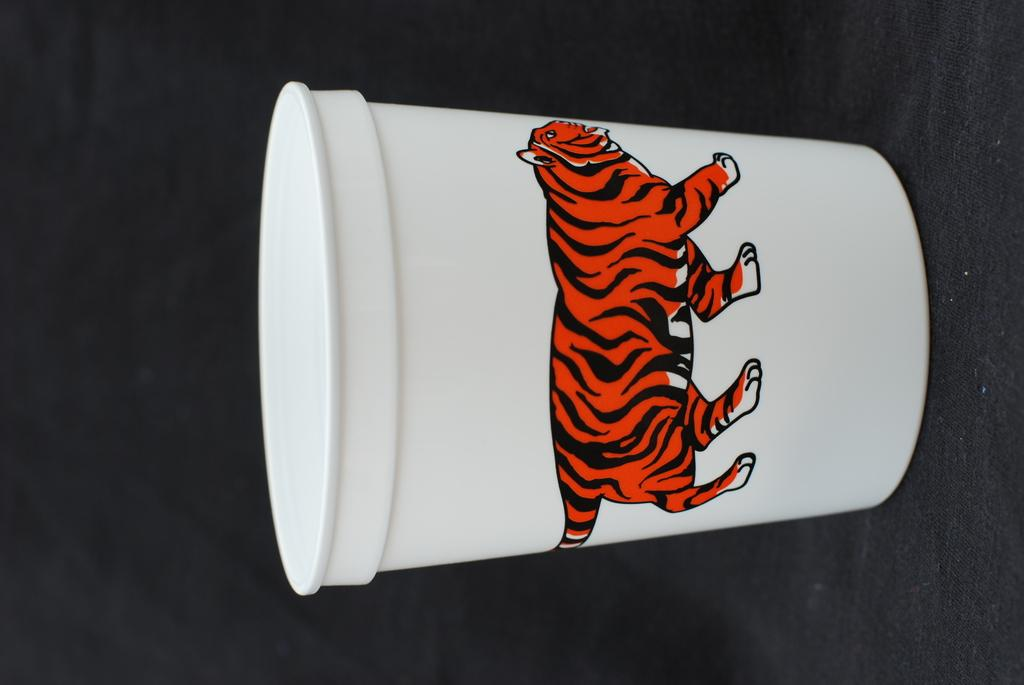What is the main subject of the image? The main subject of the image is a picture of a lion. What is the background of the picture of the lion? The picture of the lion is on a white color glass. Where is the lion located in the image? The lion is in the middle of the image. What type of recess can be seen in the image? There is no recess present in the image; it features a picture of a lion on a white color glass. What kind of trouble is the lion causing in the image? There is no indication of the lion causing any trouble in the image; it is simply a picture of a lion on a white color glass. 